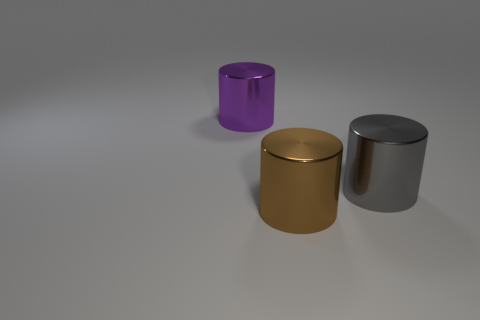How many other objects are there of the same shape as the large purple thing?
Offer a very short reply. 2. Are there any large purple things that have the same material as the brown cylinder?
Make the answer very short. Yes. Does the big object that is on the right side of the brown cylinder have the same material as the cylinder to the left of the big brown shiny cylinder?
Provide a succinct answer. Yes. How many green objects are there?
Make the answer very short. 0. The shiny object to the right of the brown metallic cylinder has what shape?
Provide a short and direct response. Cylinder. How many other objects are there of the same size as the purple metal cylinder?
Your response must be concise. 2. Does the large shiny thing on the right side of the brown object have the same shape as the big purple metallic thing to the left of the brown thing?
Offer a very short reply. Yes. There is a big gray shiny object; what number of metallic things are behind it?
Make the answer very short. 1. There is a metallic object to the right of the brown cylinder; what color is it?
Your response must be concise. Gray. Are there more red metallic cylinders than big metal cylinders?
Give a very brief answer. No. 